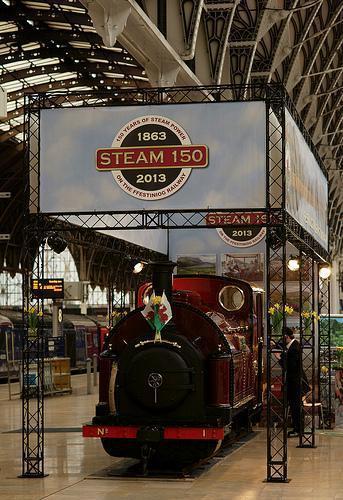How many trains are on display?
Give a very brief answer. 1. 